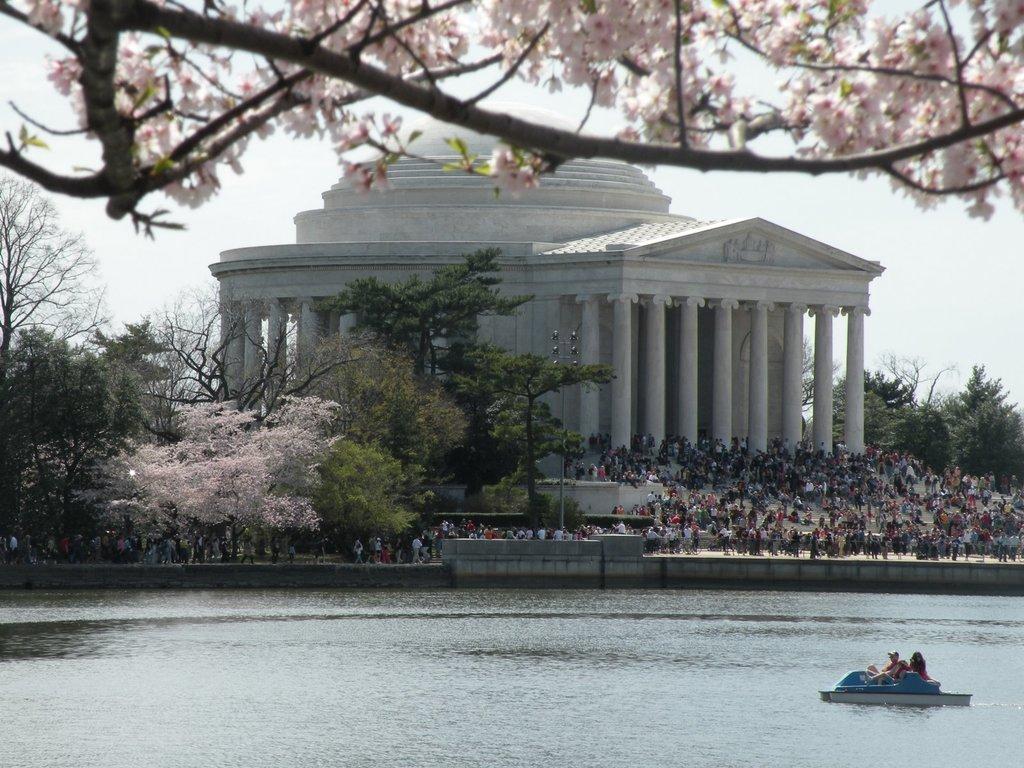Please provide a concise description of this image. In this picture I see the water in front on which there is a boat and on the boat I see 2 persons. In the background I see a building, number of trees, number of people and I see the sky. 